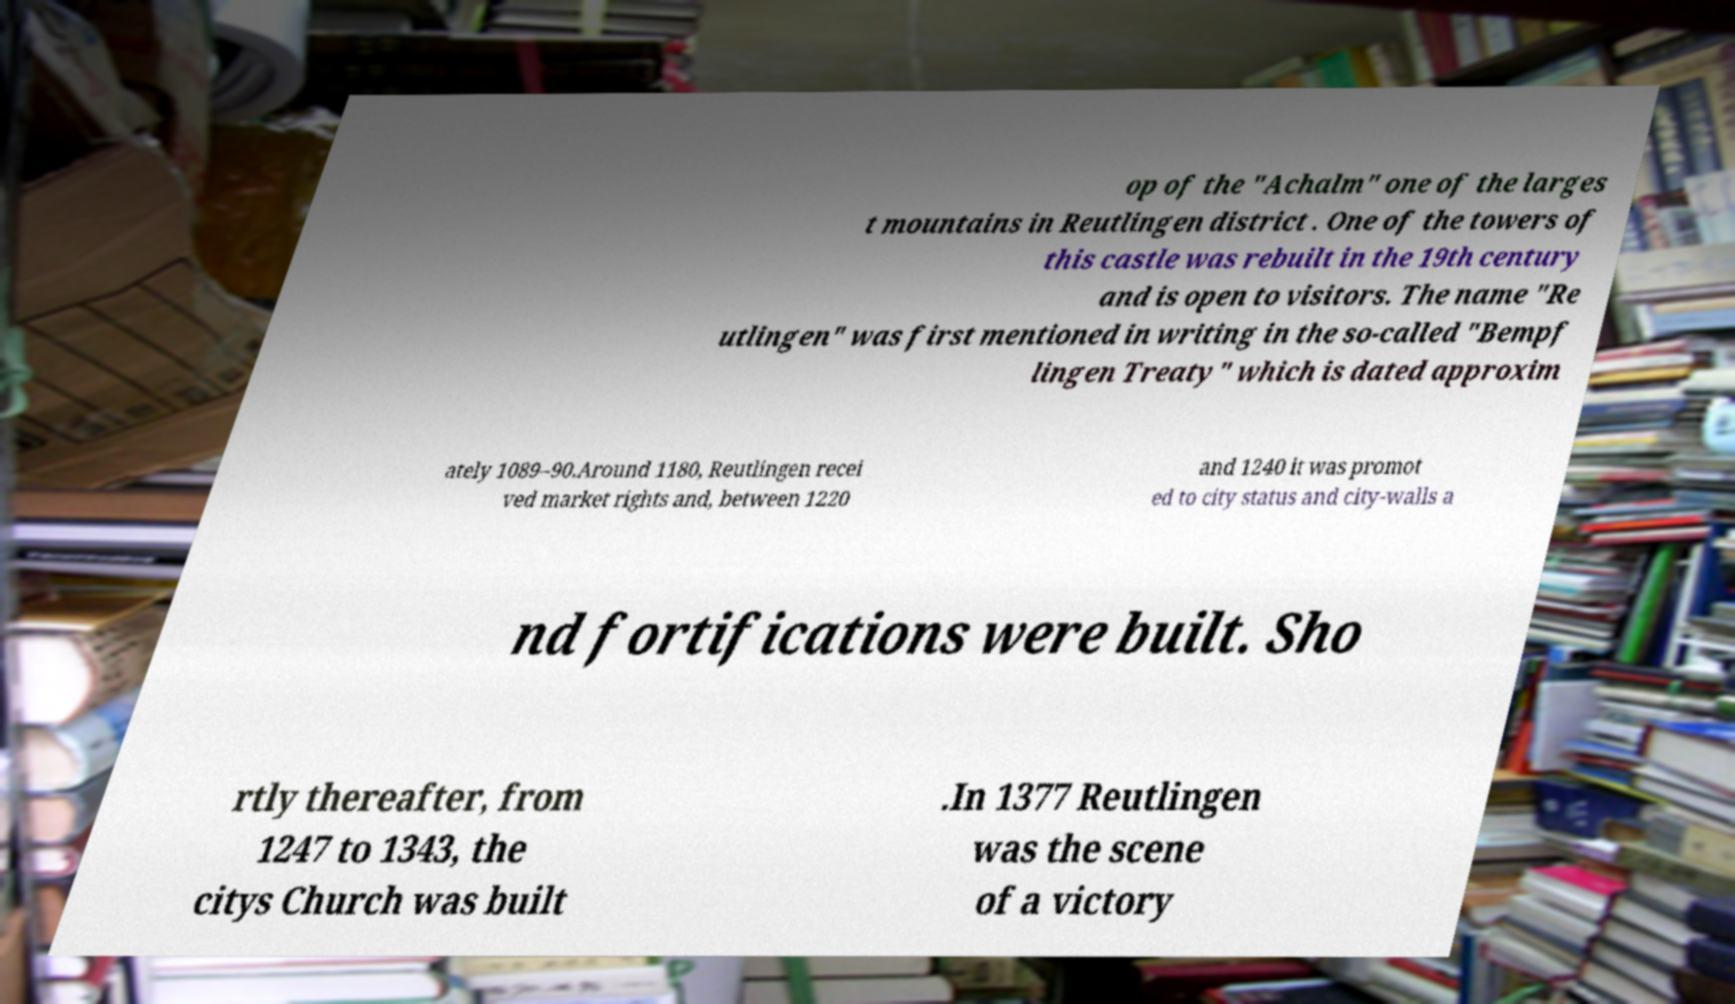Can you read and provide the text displayed in the image?This photo seems to have some interesting text. Can you extract and type it out for me? op of the "Achalm" one of the larges t mountains in Reutlingen district . One of the towers of this castle was rebuilt in the 19th century and is open to visitors. The name "Re utlingen" was first mentioned in writing in the so-called "Bempf lingen Treaty" which is dated approxim ately 1089–90.Around 1180, Reutlingen recei ved market rights and, between 1220 and 1240 it was promot ed to city status and city-walls a nd fortifications were built. Sho rtly thereafter, from 1247 to 1343, the citys Church was built .In 1377 Reutlingen was the scene of a victory 